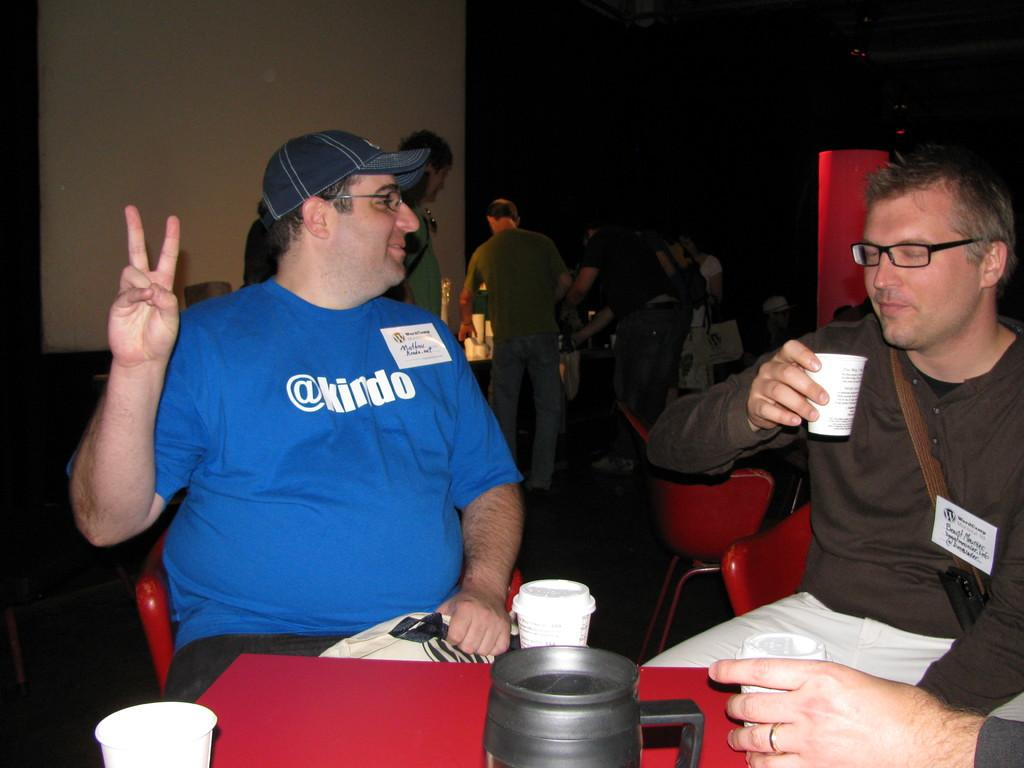What is the man in the image doing? There is a man sitting in the image. What is the man wearing? The man is wearing a blue t-shirt.shirt. Can you describe the other man in the image? There is another man on the right side of the image, and he is holding a glass in his right hand. What can be seen in the middle of the image? There is a table in the middle of the image, and it is red in color. What type of airplane can be seen flying over the table in the image? There is no airplane visible in the image; it only features two men and a table. What range of colors can be seen on the table in the image? The table in the image is red, so there is only one color visible on the table. 